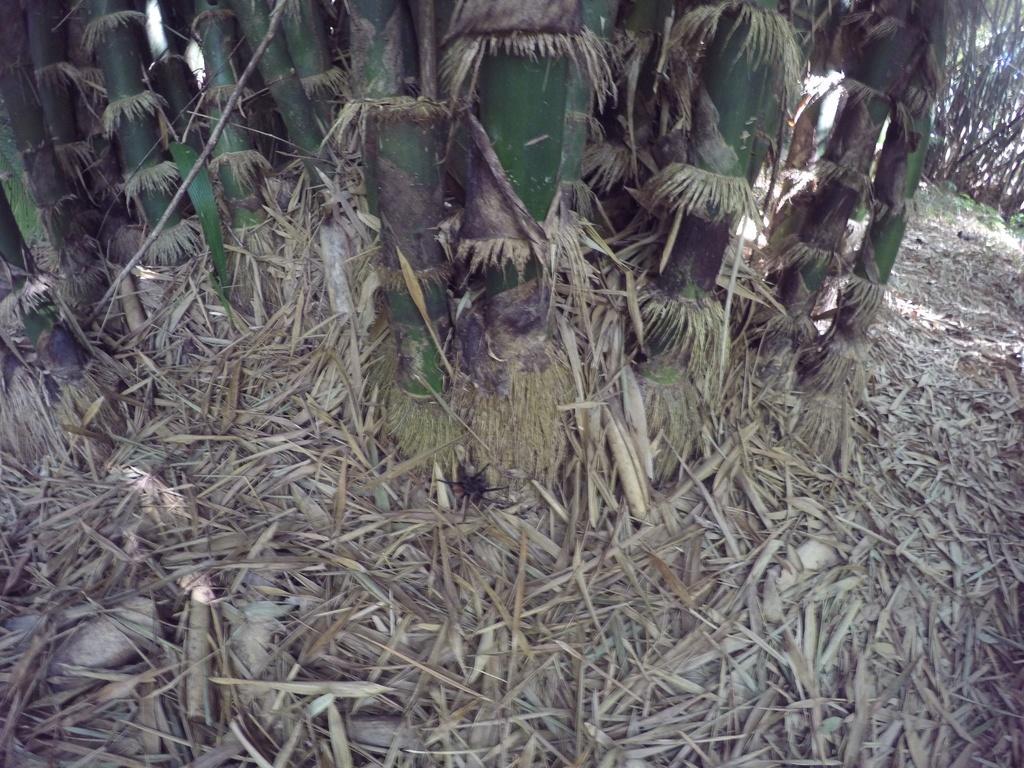In one or two sentences, can you explain what this image depicts? In this image I can see few trees and dry grass on the floor. 